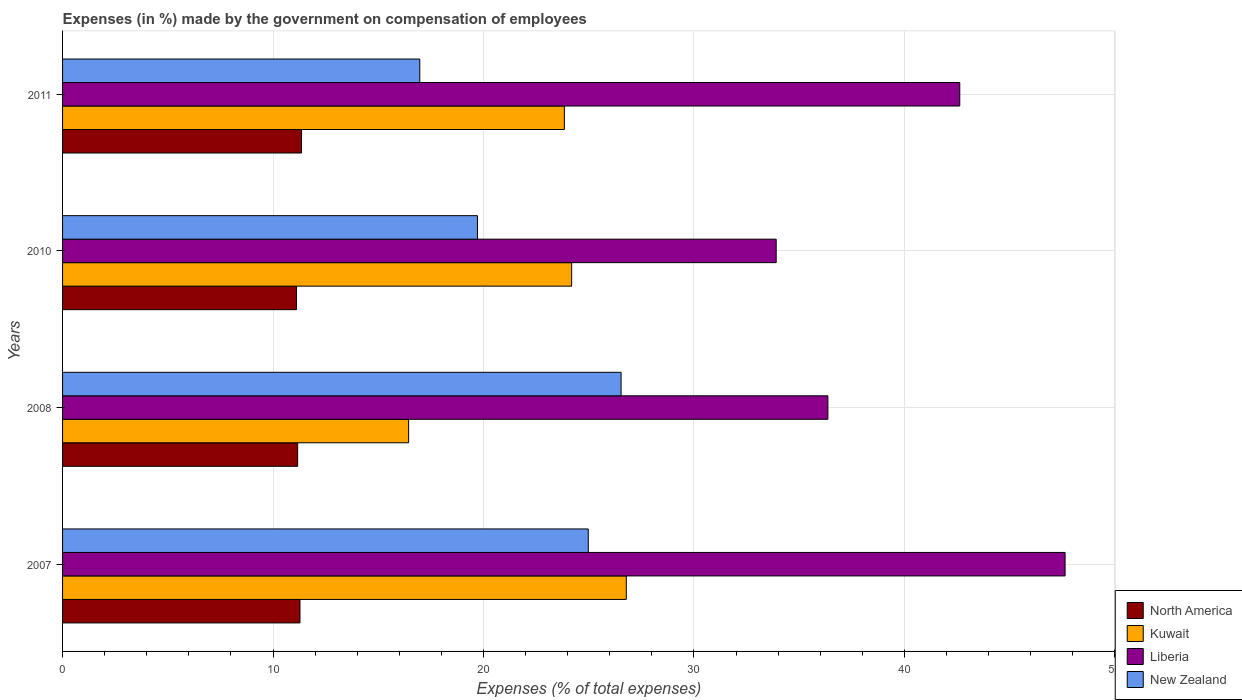How many different coloured bars are there?
Provide a short and direct response. 4. Are the number of bars per tick equal to the number of legend labels?
Offer a very short reply. Yes. Are the number of bars on each tick of the Y-axis equal?
Provide a short and direct response. Yes. What is the label of the 1st group of bars from the top?
Give a very brief answer. 2011. In how many cases, is the number of bars for a given year not equal to the number of legend labels?
Give a very brief answer. 0. What is the percentage of expenses made by the government on compensation of employees in North America in 2008?
Provide a short and direct response. 11.17. Across all years, what is the maximum percentage of expenses made by the government on compensation of employees in Kuwait?
Provide a succinct answer. 26.79. Across all years, what is the minimum percentage of expenses made by the government on compensation of employees in North America?
Provide a short and direct response. 11.12. In which year was the percentage of expenses made by the government on compensation of employees in New Zealand maximum?
Offer a terse response. 2008. In which year was the percentage of expenses made by the government on compensation of employees in Kuwait minimum?
Your answer should be very brief. 2008. What is the total percentage of expenses made by the government on compensation of employees in North America in the graph?
Provide a succinct answer. 44.92. What is the difference between the percentage of expenses made by the government on compensation of employees in New Zealand in 2008 and that in 2011?
Keep it short and to the point. 9.57. What is the difference between the percentage of expenses made by the government on compensation of employees in New Zealand in 2010 and the percentage of expenses made by the government on compensation of employees in North America in 2007?
Your answer should be compact. 8.43. What is the average percentage of expenses made by the government on compensation of employees in Liberia per year?
Provide a short and direct response. 40.13. In the year 2007, what is the difference between the percentage of expenses made by the government on compensation of employees in Liberia and percentage of expenses made by the government on compensation of employees in New Zealand?
Keep it short and to the point. 22.66. What is the ratio of the percentage of expenses made by the government on compensation of employees in New Zealand in 2010 to that in 2011?
Give a very brief answer. 1.16. Is the percentage of expenses made by the government on compensation of employees in North America in 2008 less than that in 2010?
Ensure brevity in your answer.  No. Is the difference between the percentage of expenses made by the government on compensation of employees in Liberia in 2010 and 2011 greater than the difference between the percentage of expenses made by the government on compensation of employees in New Zealand in 2010 and 2011?
Ensure brevity in your answer.  No. What is the difference between the highest and the second highest percentage of expenses made by the government on compensation of employees in New Zealand?
Make the answer very short. 1.56. What is the difference between the highest and the lowest percentage of expenses made by the government on compensation of employees in Kuwait?
Offer a terse response. 10.34. Is the sum of the percentage of expenses made by the government on compensation of employees in Liberia in 2007 and 2011 greater than the maximum percentage of expenses made by the government on compensation of employees in Kuwait across all years?
Offer a terse response. Yes. Is it the case that in every year, the sum of the percentage of expenses made by the government on compensation of employees in New Zealand and percentage of expenses made by the government on compensation of employees in Liberia is greater than the sum of percentage of expenses made by the government on compensation of employees in Kuwait and percentage of expenses made by the government on compensation of employees in North America?
Your answer should be compact. Yes. What does the 4th bar from the top in 2007 represents?
Make the answer very short. North America. What does the 1st bar from the bottom in 2010 represents?
Offer a terse response. North America. Is it the case that in every year, the sum of the percentage of expenses made by the government on compensation of employees in New Zealand and percentage of expenses made by the government on compensation of employees in North America is greater than the percentage of expenses made by the government on compensation of employees in Liberia?
Ensure brevity in your answer.  No. What is the difference between two consecutive major ticks on the X-axis?
Your response must be concise. 10. Does the graph contain grids?
Make the answer very short. Yes. How many legend labels are there?
Your response must be concise. 4. How are the legend labels stacked?
Ensure brevity in your answer.  Vertical. What is the title of the graph?
Make the answer very short. Expenses (in %) made by the government on compensation of employees. What is the label or title of the X-axis?
Keep it short and to the point. Expenses (% of total expenses). What is the Expenses (% of total expenses) of North America in 2007?
Keep it short and to the point. 11.28. What is the Expenses (% of total expenses) of Kuwait in 2007?
Ensure brevity in your answer.  26.79. What is the Expenses (% of total expenses) of Liberia in 2007?
Make the answer very short. 47.64. What is the Expenses (% of total expenses) in New Zealand in 2007?
Keep it short and to the point. 24.98. What is the Expenses (% of total expenses) in North America in 2008?
Ensure brevity in your answer.  11.17. What is the Expenses (% of total expenses) in Kuwait in 2008?
Provide a short and direct response. 16.44. What is the Expenses (% of total expenses) in Liberia in 2008?
Offer a very short reply. 36.36. What is the Expenses (% of total expenses) in New Zealand in 2008?
Ensure brevity in your answer.  26.54. What is the Expenses (% of total expenses) in North America in 2010?
Your answer should be very brief. 11.12. What is the Expenses (% of total expenses) of Kuwait in 2010?
Give a very brief answer. 24.19. What is the Expenses (% of total expenses) in Liberia in 2010?
Offer a terse response. 33.91. What is the Expenses (% of total expenses) of New Zealand in 2010?
Offer a very short reply. 19.71. What is the Expenses (% of total expenses) of North America in 2011?
Your response must be concise. 11.35. What is the Expenses (% of total expenses) in Kuwait in 2011?
Give a very brief answer. 23.84. What is the Expenses (% of total expenses) in Liberia in 2011?
Your answer should be compact. 42.63. What is the Expenses (% of total expenses) of New Zealand in 2011?
Provide a succinct answer. 16.97. Across all years, what is the maximum Expenses (% of total expenses) in North America?
Make the answer very short. 11.35. Across all years, what is the maximum Expenses (% of total expenses) of Kuwait?
Keep it short and to the point. 26.79. Across all years, what is the maximum Expenses (% of total expenses) of Liberia?
Your response must be concise. 47.64. Across all years, what is the maximum Expenses (% of total expenses) of New Zealand?
Give a very brief answer. 26.54. Across all years, what is the minimum Expenses (% of total expenses) of North America?
Offer a very short reply. 11.12. Across all years, what is the minimum Expenses (% of total expenses) in Kuwait?
Provide a short and direct response. 16.44. Across all years, what is the minimum Expenses (% of total expenses) of Liberia?
Keep it short and to the point. 33.91. Across all years, what is the minimum Expenses (% of total expenses) of New Zealand?
Your answer should be very brief. 16.97. What is the total Expenses (% of total expenses) of North America in the graph?
Keep it short and to the point. 44.92. What is the total Expenses (% of total expenses) of Kuwait in the graph?
Provide a succinct answer. 91.26. What is the total Expenses (% of total expenses) in Liberia in the graph?
Make the answer very short. 160.54. What is the total Expenses (% of total expenses) in New Zealand in the graph?
Offer a terse response. 88.2. What is the difference between the Expenses (% of total expenses) in North America in 2007 and that in 2008?
Your answer should be very brief. 0.11. What is the difference between the Expenses (% of total expenses) in Kuwait in 2007 and that in 2008?
Your answer should be compact. 10.34. What is the difference between the Expenses (% of total expenses) of Liberia in 2007 and that in 2008?
Give a very brief answer. 11.27. What is the difference between the Expenses (% of total expenses) in New Zealand in 2007 and that in 2008?
Give a very brief answer. -1.56. What is the difference between the Expenses (% of total expenses) in North America in 2007 and that in 2010?
Make the answer very short. 0.16. What is the difference between the Expenses (% of total expenses) in Kuwait in 2007 and that in 2010?
Make the answer very short. 2.6. What is the difference between the Expenses (% of total expenses) in Liberia in 2007 and that in 2010?
Offer a very short reply. 13.73. What is the difference between the Expenses (% of total expenses) of New Zealand in 2007 and that in 2010?
Offer a terse response. 5.27. What is the difference between the Expenses (% of total expenses) of North America in 2007 and that in 2011?
Your answer should be very brief. -0.07. What is the difference between the Expenses (% of total expenses) of Kuwait in 2007 and that in 2011?
Provide a short and direct response. 2.94. What is the difference between the Expenses (% of total expenses) of Liberia in 2007 and that in 2011?
Offer a very short reply. 5. What is the difference between the Expenses (% of total expenses) in New Zealand in 2007 and that in 2011?
Keep it short and to the point. 8.01. What is the difference between the Expenses (% of total expenses) of North America in 2008 and that in 2010?
Provide a succinct answer. 0.05. What is the difference between the Expenses (% of total expenses) of Kuwait in 2008 and that in 2010?
Give a very brief answer. -7.75. What is the difference between the Expenses (% of total expenses) of Liberia in 2008 and that in 2010?
Your answer should be very brief. 2.46. What is the difference between the Expenses (% of total expenses) of New Zealand in 2008 and that in 2010?
Make the answer very short. 6.83. What is the difference between the Expenses (% of total expenses) of North America in 2008 and that in 2011?
Your answer should be compact. -0.18. What is the difference between the Expenses (% of total expenses) in Kuwait in 2008 and that in 2011?
Your answer should be compact. -7.4. What is the difference between the Expenses (% of total expenses) in Liberia in 2008 and that in 2011?
Give a very brief answer. -6.27. What is the difference between the Expenses (% of total expenses) of New Zealand in 2008 and that in 2011?
Offer a terse response. 9.57. What is the difference between the Expenses (% of total expenses) of North America in 2010 and that in 2011?
Offer a very short reply. -0.24. What is the difference between the Expenses (% of total expenses) in Kuwait in 2010 and that in 2011?
Provide a short and direct response. 0.35. What is the difference between the Expenses (% of total expenses) in Liberia in 2010 and that in 2011?
Keep it short and to the point. -8.72. What is the difference between the Expenses (% of total expenses) in New Zealand in 2010 and that in 2011?
Offer a terse response. 2.74. What is the difference between the Expenses (% of total expenses) of North America in 2007 and the Expenses (% of total expenses) of Kuwait in 2008?
Your answer should be compact. -5.16. What is the difference between the Expenses (% of total expenses) of North America in 2007 and the Expenses (% of total expenses) of Liberia in 2008?
Your answer should be compact. -25.08. What is the difference between the Expenses (% of total expenses) of North America in 2007 and the Expenses (% of total expenses) of New Zealand in 2008?
Your answer should be compact. -15.26. What is the difference between the Expenses (% of total expenses) in Kuwait in 2007 and the Expenses (% of total expenses) in Liberia in 2008?
Offer a terse response. -9.58. What is the difference between the Expenses (% of total expenses) of Kuwait in 2007 and the Expenses (% of total expenses) of New Zealand in 2008?
Provide a succinct answer. 0.25. What is the difference between the Expenses (% of total expenses) of Liberia in 2007 and the Expenses (% of total expenses) of New Zealand in 2008?
Make the answer very short. 21.1. What is the difference between the Expenses (% of total expenses) in North America in 2007 and the Expenses (% of total expenses) in Kuwait in 2010?
Provide a short and direct response. -12.91. What is the difference between the Expenses (% of total expenses) of North America in 2007 and the Expenses (% of total expenses) of Liberia in 2010?
Ensure brevity in your answer.  -22.63. What is the difference between the Expenses (% of total expenses) in North America in 2007 and the Expenses (% of total expenses) in New Zealand in 2010?
Your answer should be compact. -8.43. What is the difference between the Expenses (% of total expenses) in Kuwait in 2007 and the Expenses (% of total expenses) in Liberia in 2010?
Ensure brevity in your answer.  -7.12. What is the difference between the Expenses (% of total expenses) in Kuwait in 2007 and the Expenses (% of total expenses) in New Zealand in 2010?
Ensure brevity in your answer.  7.07. What is the difference between the Expenses (% of total expenses) of Liberia in 2007 and the Expenses (% of total expenses) of New Zealand in 2010?
Your response must be concise. 27.92. What is the difference between the Expenses (% of total expenses) in North America in 2007 and the Expenses (% of total expenses) in Kuwait in 2011?
Your response must be concise. -12.56. What is the difference between the Expenses (% of total expenses) in North America in 2007 and the Expenses (% of total expenses) in Liberia in 2011?
Give a very brief answer. -31.35. What is the difference between the Expenses (% of total expenses) in North America in 2007 and the Expenses (% of total expenses) in New Zealand in 2011?
Your answer should be compact. -5.69. What is the difference between the Expenses (% of total expenses) in Kuwait in 2007 and the Expenses (% of total expenses) in Liberia in 2011?
Ensure brevity in your answer.  -15.84. What is the difference between the Expenses (% of total expenses) in Kuwait in 2007 and the Expenses (% of total expenses) in New Zealand in 2011?
Offer a very short reply. 9.81. What is the difference between the Expenses (% of total expenses) in Liberia in 2007 and the Expenses (% of total expenses) in New Zealand in 2011?
Your answer should be very brief. 30.66. What is the difference between the Expenses (% of total expenses) of North America in 2008 and the Expenses (% of total expenses) of Kuwait in 2010?
Keep it short and to the point. -13.02. What is the difference between the Expenses (% of total expenses) of North America in 2008 and the Expenses (% of total expenses) of Liberia in 2010?
Offer a very short reply. -22.74. What is the difference between the Expenses (% of total expenses) in North America in 2008 and the Expenses (% of total expenses) in New Zealand in 2010?
Your response must be concise. -8.54. What is the difference between the Expenses (% of total expenses) in Kuwait in 2008 and the Expenses (% of total expenses) in Liberia in 2010?
Offer a very short reply. -17.46. What is the difference between the Expenses (% of total expenses) in Kuwait in 2008 and the Expenses (% of total expenses) in New Zealand in 2010?
Offer a very short reply. -3.27. What is the difference between the Expenses (% of total expenses) in Liberia in 2008 and the Expenses (% of total expenses) in New Zealand in 2010?
Offer a terse response. 16.65. What is the difference between the Expenses (% of total expenses) in North America in 2008 and the Expenses (% of total expenses) in Kuwait in 2011?
Make the answer very short. -12.67. What is the difference between the Expenses (% of total expenses) in North America in 2008 and the Expenses (% of total expenses) in Liberia in 2011?
Provide a short and direct response. -31.46. What is the difference between the Expenses (% of total expenses) of North America in 2008 and the Expenses (% of total expenses) of New Zealand in 2011?
Offer a very short reply. -5.8. What is the difference between the Expenses (% of total expenses) in Kuwait in 2008 and the Expenses (% of total expenses) in Liberia in 2011?
Offer a terse response. -26.19. What is the difference between the Expenses (% of total expenses) in Kuwait in 2008 and the Expenses (% of total expenses) in New Zealand in 2011?
Ensure brevity in your answer.  -0.53. What is the difference between the Expenses (% of total expenses) of Liberia in 2008 and the Expenses (% of total expenses) of New Zealand in 2011?
Give a very brief answer. 19.39. What is the difference between the Expenses (% of total expenses) of North America in 2010 and the Expenses (% of total expenses) of Kuwait in 2011?
Provide a succinct answer. -12.73. What is the difference between the Expenses (% of total expenses) of North America in 2010 and the Expenses (% of total expenses) of Liberia in 2011?
Provide a short and direct response. -31.51. What is the difference between the Expenses (% of total expenses) of North America in 2010 and the Expenses (% of total expenses) of New Zealand in 2011?
Ensure brevity in your answer.  -5.86. What is the difference between the Expenses (% of total expenses) of Kuwait in 2010 and the Expenses (% of total expenses) of Liberia in 2011?
Offer a very short reply. -18.44. What is the difference between the Expenses (% of total expenses) of Kuwait in 2010 and the Expenses (% of total expenses) of New Zealand in 2011?
Your response must be concise. 7.22. What is the difference between the Expenses (% of total expenses) in Liberia in 2010 and the Expenses (% of total expenses) in New Zealand in 2011?
Offer a very short reply. 16.93. What is the average Expenses (% of total expenses) of North America per year?
Make the answer very short. 11.23. What is the average Expenses (% of total expenses) in Kuwait per year?
Provide a short and direct response. 22.82. What is the average Expenses (% of total expenses) in Liberia per year?
Give a very brief answer. 40.13. What is the average Expenses (% of total expenses) of New Zealand per year?
Keep it short and to the point. 22.05. In the year 2007, what is the difference between the Expenses (% of total expenses) in North America and Expenses (% of total expenses) in Kuwait?
Ensure brevity in your answer.  -15.51. In the year 2007, what is the difference between the Expenses (% of total expenses) in North America and Expenses (% of total expenses) in Liberia?
Your answer should be very brief. -36.35. In the year 2007, what is the difference between the Expenses (% of total expenses) in North America and Expenses (% of total expenses) in New Zealand?
Offer a terse response. -13.7. In the year 2007, what is the difference between the Expenses (% of total expenses) in Kuwait and Expenses (% of total expenses) in Liberia?
Your answer should be compact. -20.85. In the year 2007, what is the difference between the Expenses (% of total expenses) in Kuwait and Expenses (% of total expenses) in New Zealand?
Offer a terse response. 1.81. In the year 2007, what is the difference between the Expenses (% of total expenses) of Liberia and Expenses (% of total expenses) of New Zealand?
Provide a short and direct response. 22.66. In the year 2008, what is the difference between the Expenses (% of total expenses) in North America and Expenses (% of total expenses) in Kuwait?
Make the answer very short. -5.27. In the year 2008, what is the difference between the Expenses (% of total expenses) in North America and Expenses (% of total expenses) in Liberia?
Provide a succinct answer. -25.19. In the year 2008, what is the difference between the Expenses (% of total expenses) of North America and Expenses (% of total expenses) of New Zealand?
Your response must be concise. -15.37. In the year 2008, what is the difference between the Expenses (% of total expenses) of Kuwait and Expenses (% of total expenses) of Liberia?
Provide a short and direct response. -19.92. In the year 2008, what is the difference between the Expenses (% of total expenses) in Kuwait and Expenses (% of total expenses) in New Zealand?
Offer a terse response. -10.1. In the year 2008, what is the difference between the Expenses (% of total expenses) of Liberia and Expenses (% of total expenses) of New Zealand?
Provide a short and direct response. 9.83. In the year 2010, what is the difference between the Expenses (% of total expenses) of North America and Expenses (% of total expenses) of Kuwait?
Make the answer very short. -13.07. In the year 2010, what is the difference between the Expenses (% of total expenses) in North America and Expenses (% of total expenses) in Liberia?
Provide a short and direct response. -22.79. In the year 2010, what is the difference between the Expenses (% of total expenses) of North America and Expenses (% of total expenses) of New Zealand?
Offer a very short reply. -8.6. In the year 2010, what is the difference between the Expenses (% of total expenses) in Kuwait and Expenses (% of total expenses) in Liberia?
Offer a terse response. -9.72. In the year 2010, what is the difference between the Expenses (% of total expenses) in Kuwait and Expenses (% of total expenses) in New Zealand?
Make the answer very short. 4.48. In the year 2010, what is the difference between the Expenses (% of total expenses) of Liberia and Expenses (% of total expenses) of New Zealand?
Your answer should be compact. 14.19. In the year 2011, what is the difference between the Expenses (% of total expenses) of North America and Expenses (% of total expenses) of Kuwait?
Your response must be concise. -12.49. In the year 2011, what is the difference between the Expenses (% of total expenses) in North America and Expenses (% of total expenses) in Liberia?
Give a very brief answer. -31.28. In the year 2011, what is the difference between the Expenses (% of total expenses) in North America and Expenses (% of total expenses) in New Zealand?
Provide a short and direct response. -5.62. In the year 2011, what is the difference between the Expenses (% of total expenses) in Kuwait and Expenses (% of total expenses) in Liberia?
Provide a short and direct response. -18.79. In the year 2011, what is the difference between the Expenses (% of total expenses) in Kuwait and Expenses (% of total expenses) in New Zealand?
Offer a terse response. 6.87. In the year 2011, what is the difference between the Expenses (% of total expenses) of Liberia and Expenses (% of total expenses) of New Zealand?
Keep it short and to the point. 25.66. What is the ratio of the Expenses (% of total expenses) in North America in 2007 to that in 2008?
Ensure brevity in your answer.  1.01. What is the ratio of the Expenses (% of total expenses) in Kuwait in 2007 to that in 2008?
Your answer should be compact. 1.63. What is the ratio of the Expenses (% of total expenses) in Liberia in 2007 to that in 2008?
Offer a very short reply. 1.31. What is the ratio of the Expenses (% of total expenses) of New Zealand in 2007 to that in 2008?
Offer a terse response. 0.94. What is the ratio of the Expenses (% of total expenses) in North America in 2007 to that in 2010?
Offer a very short reply. 1.01. What is the ratio of the Expenses (% of total expenses) of Kuwait in 2007 to that in 2010?
Your answer should be compact. 1.11. What is the ratio of the Expenses (% of total expenses) of Liberia in 2007 to that in 2010?
Offer a very short reply. 1.4. What is the ratio of the Expenses (% of total expenses) of New Zealand in 2007 to that in 2010?
Offer a very short reply. 1.27. What is the ratio of the Expenses (% of total expenses) in Kuwait in 2007 to that in 2011?
Keep it short and to the point. 1.12. What is the ratio of the Expenses (% of total expenses) of Liberia in 2007 to that in 2011?
Provide a short and direct response. 1.12. What is the ratio of the Expenses (% of total expenses) in New Zealand in 2007 to that in 2011?
Keep it short and to the point. 1.47. What is the ratio of the Expenses (% of total expenses) in North America in 2008 to that in 2010?
Provide a short and direct response. 1. What is the ratio of the Expenses (% of total expenses) of Kuwait in 2008 to that in 2010?
Keep it short and to the point. 0.68. What is the ratio of the Expenses (% of total expenses) in Liberia in 2008 to that in 2010?
Offer a very short reply. 1.07. What is the ratio of the Expenses (% of total expenses) of New Zealand in 2008 to that in 2010?
Give a very brief answer. 1.35. What is the ratio of the Expenses (% of total expenses) in North America in 2008 to that in 2011?
Your answer should be compact. 0.98. What is the ratio of the Expenses (% of total expenses) in Kuwait in 2008 to that in 2011?
Provide a short and direct response. 0.69. What is the ratio of the Expenses (% of total expenses) in Liberia in 2008 to that in 2011?
Your response must be concise. 0.85. What is the ratio of the Expenses (% of total expenses) in New Zealand in 2008 to that in 2011?
Offer a very short reply. 1.56. What is the ratio of the Expenses (% of total expenses) in North America in 2010 to that in 2011?
Provide a short and direct response. 0.98. What is the ratio of the Expenses (% of total expenses) in Kuwait in 2010 to that in 2011?
Offer a terse response. 1.01. What is the ratio of the Expenses (% of total expenses) of Liberia in 2010 to that in 2011?
Offer a terse response. 0.8. What is the ratio of the Expenses (% of total expenses) in New Zealand in 2010 to that in 2011?
Your response must be concise. 1.16. What is the difference between the highest and the second highest Expenses (% of total expenses) in North America?
Offer a terse response. 0.07. What is the difference between the highest and the second highest Expenses (% of total expenses) of Kuwait?
Give a very brief answer. 2.6. What is the difference between the highest and the second highest Expenses (% of total expenses) in Liberia?
Offer a terse response. 5. What is the difference between the highest and the second highest Expenses (% of total expenses) in New Zealand?
Give a very brief answer. 1.56. What is the difference between the highest and the lowest Expenses (% of total expenses) in North America?
Give a very brief answer. 0.24. What is the difference between the highest and the lowest Expenses (% of total expenses) in Kuwait?
Offer a terse response. 10.34. What is the difference between the highest and the lowest Expenses (% of total expenses) of Liberia?
Make the answer very short. 13.73. What is the difference between the highest and the lowest Expenses (% of total expenses) in New Zealand?
Offer a terse response. 9.57. 